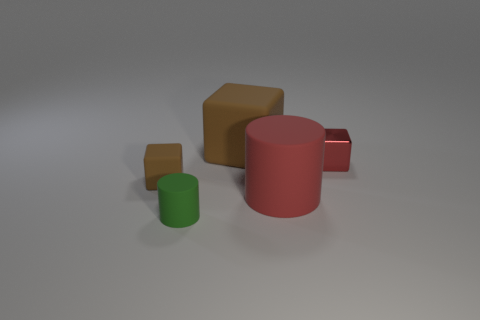What is the size relationship between the objects? There are two different size relationships evident. The green cylinder is smaller than the red cylinder, and similarly, the small brown cube is smaller than the larger brown cube. This creates an interesting hierarchy of scale from small to large. 